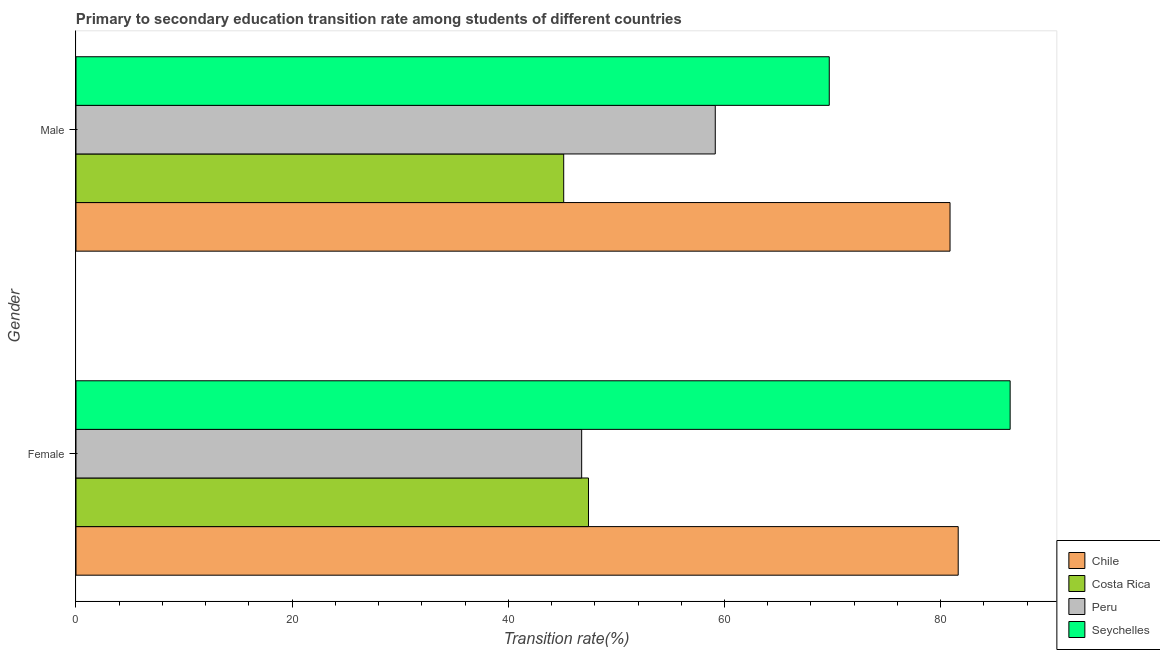Are the number of bars on each tick of the Y-axis equal?
Provide a succinct answer. Yes. How many bars are there on the 1st tick from the top?
Give a very brief answer. 4. What is the transition rate among female students in Costa Rica?
Your answer should be compact. 47.42. Across all countries, what is the maximum transition rate among female students?
Your answer should be very brief. 86.43. Across all countries, what is the minimum transition rate among female students?
Keep it short and to the point. 46.79. In which country was the transition rate among female students maximum?
Provide a short and direct response. Seychelles. In which country was the transition rate among male students minimum?
Offer a very short reply. Costa Rica. What is the total transition rate among male students in the graph?
Offer a very short reply. 254.84. What is the difference between the transition rate among male students in Seychelles and that in Costa Rica?
Your answer should be compact. 24.57. What is the difference between the transition rate among female students in Costa Rica and the transition rate among male students in Chile?
Provide a short and direct response. -33.45. What is the average transition rate among female students per country?
Offer a very short reply. 65.57. What is the difference between the transition rate among male students and transition rate among female students in Seychelles?
Provide a succinct answer. -16.74. In how many countries, is the transition rate among male students greater than 4 %?
Make the answer very short. 4. What is the ratio of the transition rate among male students in Costa Rica to that in Peru?
Make the answer very short. 0.76. Is the transition rate among female students in Chile less than that in Seychelles?
Provide a succinct answer. Yes. What does the 4th bar from the bottom in Female represents?
Ensure brevity in your answer.  Seychelles. How many bars are there?
Give a very brief answer. 8. How many countries are there in the graph?
Provide a succinct answer. 4. What is the difference between two consecutive major ticks on the X-axis?
Provide a succinct answer. 20. Are the values on the major ticks of X-axis written in scientific E-notation?
Keep it short and to the point. No. Does the graph contain grids?
Your response must be concise. No. How many legend labels are there?
Make the answer very short. 4. What is the title of the graph?
Keep it short and to the point. Primary to secondary education transition rate among students of different countries. Does "Honduras" appear as one of the legend labels in the graph?
Your answer should be compact. No. What is the label or title of the X-axis?
Your answer should be compact. Transition rate(%). What is the Transition rate(%) of Chile in Female?
Offer a very short reply. 81.63. What is the Transition rate(%) of Costa Rica in Female?
Keep it short and to the point. 47.42. What is the Transition rate(%) of Peru in Female?
Ensure brevity in your answer.  46.79. What is the Transition rate(%) of Seychelles in Female?
Your response must be concise. 86.43. What is the Transition rate(%) of Chile in Male?
Your response must be concise. 80.87. What is the Transition rate(%) in Costa Rica in Male?
Your answer should be very brief. 45.13. What is the Transition rate(%) in Peru in Male?
Ensure brevity in your answer.  59.15. What is the Transition rate(%) in Seychelles in Male?
Provide a succinct answer. 69.7. Across all Gender, what is the maximum Transition rate(%) of Chile?
Your answer should be compact. 81.63. Across all Gender, what is the maximum Transition rate(%) in Costa Rica?
Your answer should be very brief. 47.42. Across all Gender, what is the maximum Transition rate(%) of Peru?
Make the answer very short. 59.15. Across all Gender, what is the maximum Transition rate(%) of Seychelles?
Offer a very short reply. 86.43. Across all Gender, what is the minimum Transition rate(%) of Chile?
Provide a succinct answer. 80.87. Across all Gender, what is the minimum Transition rate(%) of Costa Rica?
Provide a short and direct response. 45.13. Across all Gender, what is the minimum Transition rate(%) of Peru?
Provide a short and direct response. 46.79. Across all Gender, what is the minimum Transition rate(%) in Seychelles?
Keep it short and to the point. 69.7. What is the total Transition rate(%) in Chile in the graph?
Your answer should be compact. 162.5. What is the total Transition rate(%) of Costa Rica in the graph?
Give a very brief answer. 92.54. What is the total Transition rate(%) of Peru in the graph?
Give a very brief answer. 105.94. What is the total Transition rate(%) of Seychelles in the graph?
Make the answer very short. 156.13. What is the difference between the Transition rate(%) of Chile in Female and that in Male?
Give a very brief answer. 0.76. What is the difference between the Transition rate(%) in Costa Rica in Female and that in Male?
Offer a terse response. 2.29. What is the difference between the Transition rate(%) of Peru in Female and that in Male?
Provide a succinct answer. -12.36. What is the difference between the Transition rate(%) of Seychelles in Female and that in Male?
Your answer should be very brief. 16.74. What is the difference between the Transition rate(%) in Chile in Female and the Transition rate(%) in Costa Rica in Male?
Your answer should be compact. 36.5. What is the difference between the Transition rate(%) in Chile in Female and the Transition rate(%) in Peru in Male?
Keep it short and to the point. 22.48. What is the difference between the Transition rate(%) in Chile in Female and the Transition rate(%) in Seychelles in Male?
Provide a short and direct response. 11.93. What is the difference between the Transition rate(%) in Costa Rica in Female and the Transition rate(%) in Peru in Male?
Your response must be concise. -11.73. What is the difference between the Transition rate(%) of Costa Rica in Female and the Transition rate(%) of Seychelles in Male?
Provide a short and direct response. -22.28. What is the difference between the Transition rate(%) of Peru in Female and the Transition rate(%) of Seychelles in Male?
Your response must be concise. -22.91. What is the average Transition rate(%) in Chile per Gender?
Offer a terse response. 81.25. What is the average Transition rate(%) of Costa Rica per Gender?
Keep it short and to the point. 46.27. What is the average Transition rate(%) of Peru per Gender?
Your response must be concise. 52.97. What is the average Transition rate(%) in Seychelles per Gender?
Offer a terse response. 78.06. What is the difference between the Transition rate(%) of Chile and Transition rate(%) of Costa Rica in Female?
Your answer should be very brief. 34.21. What is the difference between the Transition rate(%) in Chile and Transition rate(%) in Peru in Female?
Your answer should be compact. 34.84. What is the difference between the Transition rate(%) of Chile and Transition rate(%) of Seychelles in Female?
Offer a very short reply. -4.81. What is the difference between the Transition rate(%) in Costa Rica and Transition rate(%) in Peru in Female?
Offer a very short reply. 0.63. What is the difference between the Transition rate(%) of Costa Rica and Transition rate(%) of Seychelles in Female?
Keep it short and to the point. -39.01. What is the difference between the Transition rate(%) in Peru and Transition rate(%) in Seychelles in Female?
Give a very brief answer. -39.64. What is the difference between the Transition rate(%) of Chile and Transition rate(%) of Costa Rica in Male?
Keep it short and to the point. 35.75. What is the difference between the Transition rate(%) of Chile and Transition rate(%) of Peru in Male?
Offer a very short reply. 21.72. What is the difference between the Transition rate(%) of Chile and Transition rate(%) of Seychelles in Male?
Ensure brevity in your answer.  11.17. What is the difference between the Transition rate(%) of Costa Rica and Transition rate(%) of Peru in Male?
Offer a terse response. -14.02. What is the difference between the Transition rate(%) in Costa Rica and Transition rate(%) in Seychelles in Male?
Offer a terse response. -24.57. What is the difference between the Transition rate(%) in Peru and Transition rate(%) in Seychelles in Male?
Offer a very short reply. -10.55. What is the ratio of the Transition rate(%) in Chile in Female to that in Male?
Provide a succinct answer. 1.01. What is the ratio of the Transition rate(%) of Costa Rica in Female to that in Male?
Give a very brief answer. 1.05. What is the ratio of the Transition rate(%) in Peru in Female to that in Male?
Ensure brevity in your answer.  0.79. What is the ratio of the Transition rate(%) in Seychelles in Female to that in Male?
Make the answer very short. 1.24. What is the difference between the highest and the second highest Transition rate(%) in Chile?
Offer a very short reply. 0.76. What is the difference between the highest and the second highest Transition rate(%) of Costa Rica?
Give a very brief answer. 2.29. What is the difference between the highest and the second highest Transition rate(%) of Peru?
Provide a succinct answer. 12.36. What is the difference between the highest and the second highest Transition rate(%) in Seychelles?
Give a very brief answer. 16.74. What is the difference between the highest and the lowest Transition rate(%) of Chile?
Your answer should be very brief. 0.76. What is the difference between the highest and the lowest Transition rate(%) of Costa Rica?
Your answer should be compact. 2.29. What is the difference between the highest and the lowest Transition rate(%) of Peru?
Provide a succinct answer. 12.36. What is the difference between the highest and the lowest Transition rate(%) in Seychelles?
Ensure brevity in your answer.  16.74. 